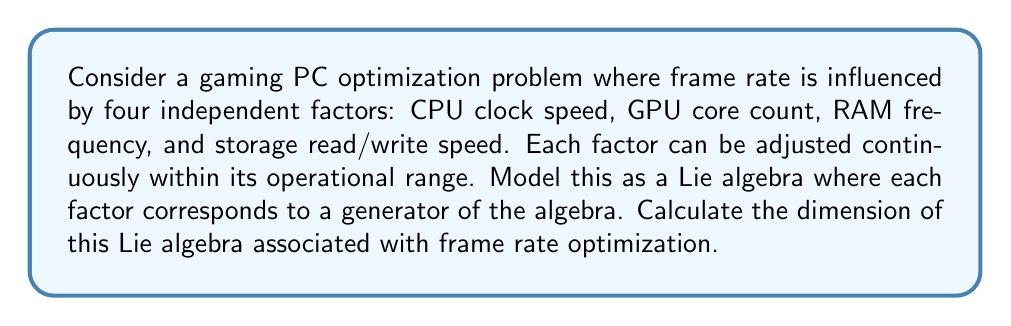Solve this math problem. To determine the dimension of the Lie algebra associated with frame rate optimization, we need to understand the following concepts:

1. In this context, each independent factor that influences frame rate can be considered as a generator of the Lie algebra.

2. The dimension of a Lie algebra is equal to the number of its linearly independent generators.

3. We are given four independent factors:
   a. CPU clock speed
   b. GPU core count
   c. RAM frequency
   d. Storage read/write speed

4. Each of these factors can be adjusted continuously within its operational range, which means they can be represented as smooth vector fields on a manifold (in this case, the space of possible system configurations).

5. Since these factors are stated to be independent, they form a basis for the Lie algebra.

6. In Lie algebra theory, the dimension is determined by counting the number of linearly independent generators.

Therefore, the dimension of the Lie algebra is equal to the number of independent factors, which is 4 in this case.

Mathematically, we can represent this Lie algebra as:

$$ \mathfrak{g} = \text{span}\{X_1, X_2, X_3, X_4\} $$

where $X_1, X_2, X_3,$ and $X_4$ represent the generators corresponding to CPU clock speed, GPU core count, RAM frequency, and storage read/write speed, respectively.

The dimension of this Lie algebra is given by:

$$ \dim(\mathfrak{g}) = 4 $$
Answer: The dimension of the Lie algebra associated with frame rate optimization in this gaming PC scenario is 4. 